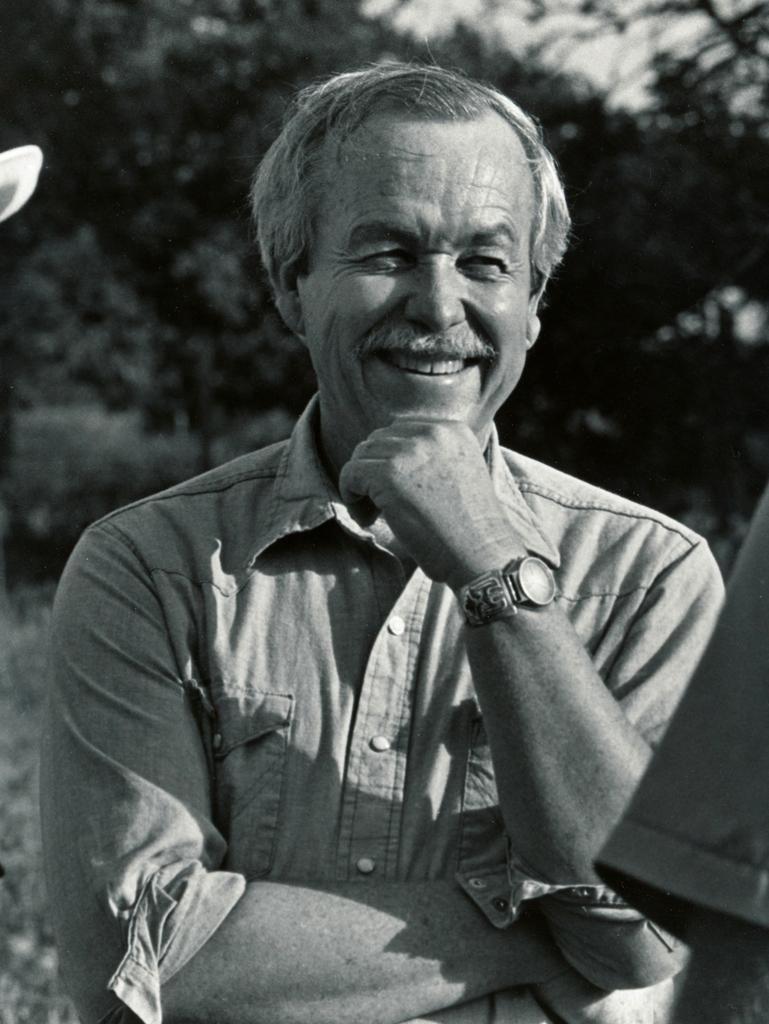What type of picture is in the image? The image contains a black and white picture of a person. What is the person in the picture wearing? The person in the picture is wearing a shirt and a watch. What is the facial expression of the person in the picture? The person in the picture is smiling. What can be seen in the background of the image? There are trees visible in the background of the image. What hobbies does the person in the picture have? There is no information about the person's hobbies in the image. 